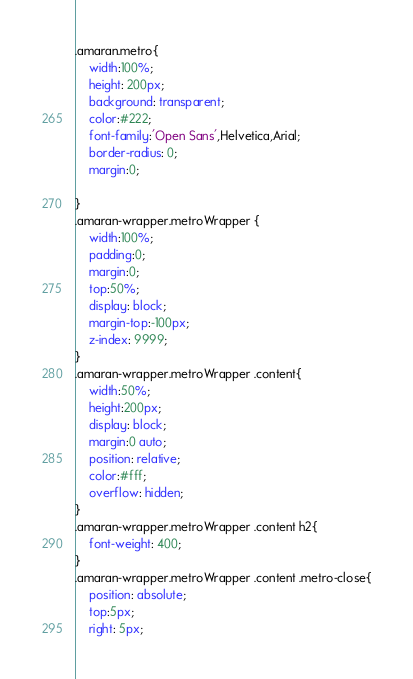<code> <loc_0><loc_0><loc_500><loc_500><_CSS_>.amaran.metro{
    width:100%;
    height: 200px;
    background: transparent;
    color:#222;
    font-family:'Open Sans',Helvetica,Arial;
    border-radius: 0;
    margin:0;

}
.amaran-wrapper.metroWrapper {
    width:100%;
    padding:0;
    margin:0;
    top:50%;
    display: block;
    margin-top:-100px;
    z-index: 9999;
}
.amaran-wrapper.metroWrapper .content{
    width:50%;
    height:200px;
    display: block;
    margin:0 auto;
    position: relative;
    color:#fff;
    overflow: hidden;
}
.amaran-wrapper.metroWrapper .content h2{
    font-weight: 400;
}
.amaran-wrapper.metroWrapper .content .metro-close{
    position: absolute;
    top:5px;
    right: 5px;</code> 